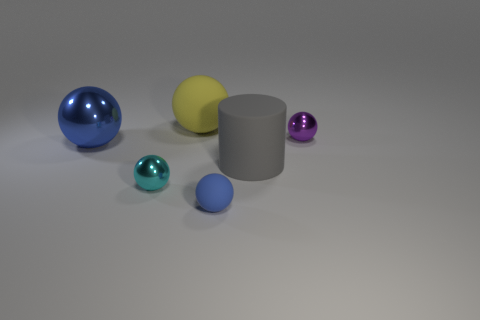There is a tiny rubber object that is the same color as the big metal thing; what is its shape?
Your response must be concise. Sphere. What number of cyan balls are on the left side of the ball right of the blue rubber sphere?
Ensure brevity in your answer.  1. What number of large gray cylinders have the same material as the tiny purple ball?
Keep it short and to the point. 0. Are there any large yellow rubber balls in front of the small blue thing?
Your answer should be very brief. No. There is a metal sphere that is the same size as the gray object; what is its color?
Provide a short and direct response. Blue. What number of objects are either small objects right of the rubber cylinder or small purple metal balls?
Offer a very short reply. 1. What size is the thing that is both behind the blue metallic thing and on the right side of the tiny blue rubber sphere?
Give a very brief answer. Small. The other ball that is the same color as the small matte ball is what size?
Offer a very short reply. Large. How many other objects are the same size as the cyan thing?
Your answer should be compact. 2. What color is the tiny thing right of the big rubber thing in front of the metallic thing that is right of the large yellow object?
Provide a succinct answer. Purple. 